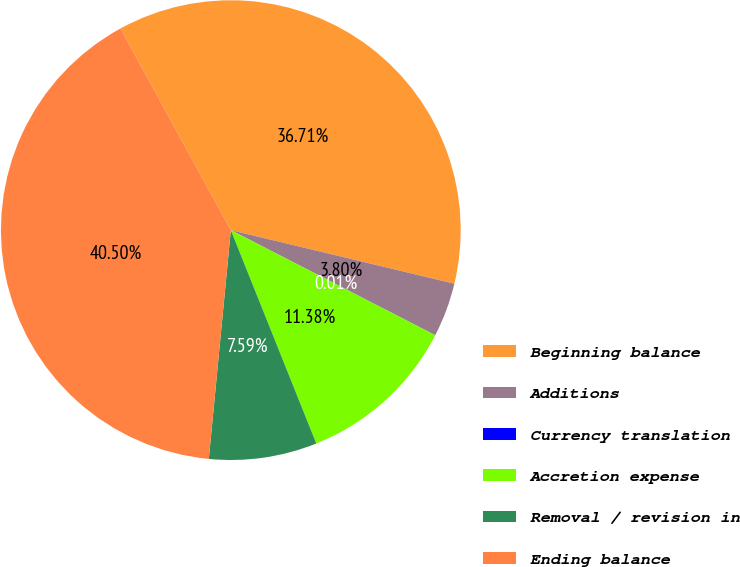<chart> <loc_0><loc_0><loc_500><loc_500><pie_chart><fcel>Beginning balance<fcel>Additions<fcel>Currency translation<fcel>Accretion expense<fcel>Removal / revision in<fcel>Ending balance<nl><fcel>36.71%<fcel>3.8%<fcel>0.01%<fcel>11.38%<fcel>7.59%<fcel>40.5%<nl></chart> 